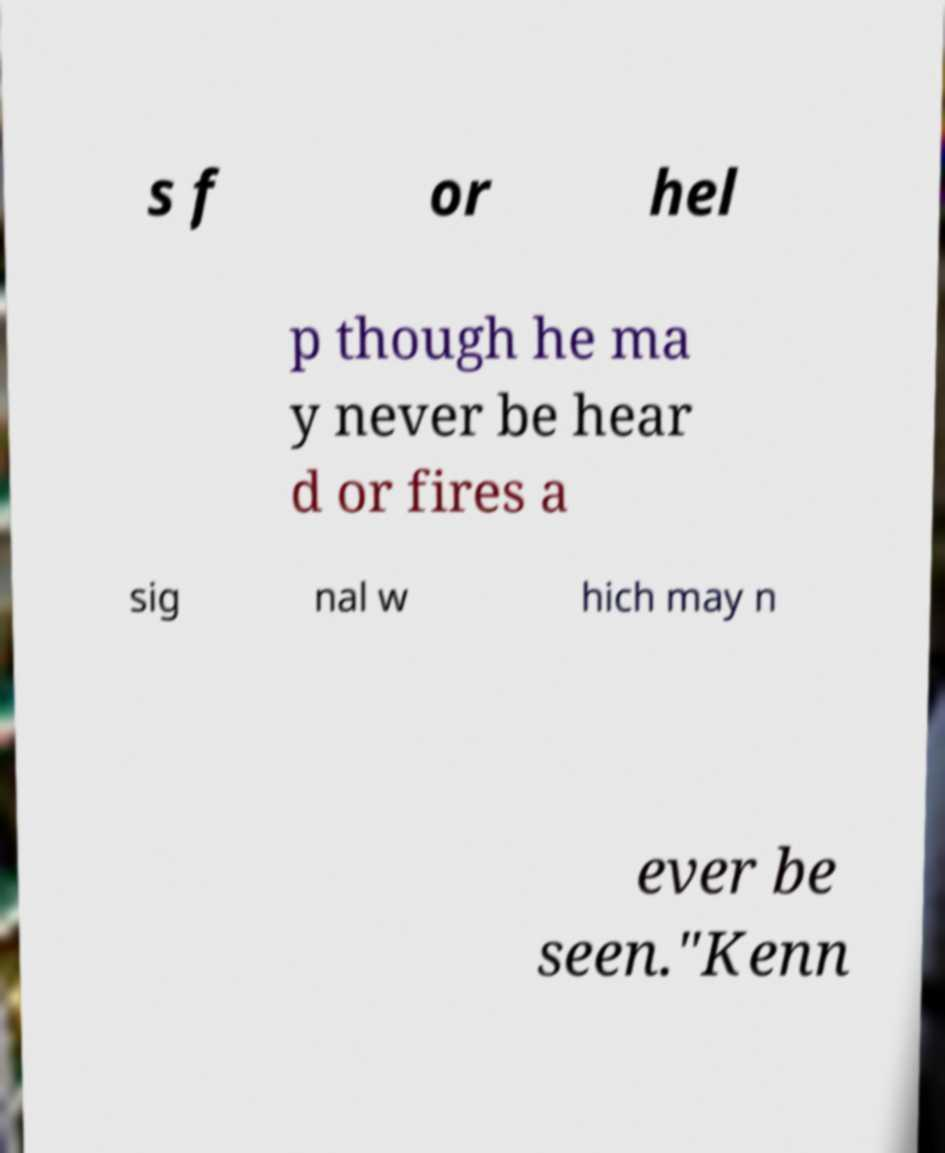Please identify and transcribe the text found in this image. s f or hel p though he ma y never be hear d or fires a sig nal w hich may n ever be seen."Kenn 